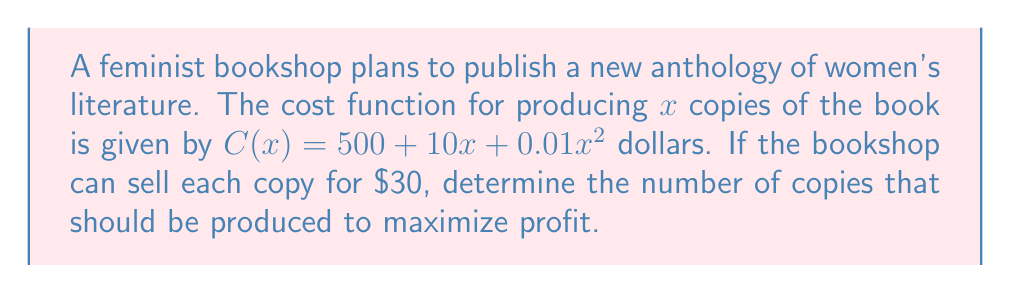Help me with this question. 1. Define the profit function:
   Profit = Revenue - Cost
   $P(x) = 30x - (500 + 10x + 0.01x^2)$
   $P(x) = 30x - 500 - 10x - 0.01x^2$
   $P(x) = 20x - 500 - 0.01x^2$

2. To find the maximum profit, we need to find the derivative of P(x) and set it equal to zero:
   $$\frac{dP}{dx} = 20 - 0.02x$$

3. Set the derivative equal to zero and solve for x:
   $20 - 0.02x = 0$
   $20 = 0.02x$
   $x = 1000$

4. To confirm this is a maximum, check the second derivative:
   $$\frac{d^2P}{dx^2} = -0.02$$
   Since this is negative, the critical point is a maximum.

5. Therefore, the profit is maximized when 1000 copies are produced.
Answer: 1000 copies 